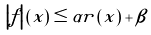Convert formula to latex. <formula><loc_0><loc_0><loc_500><loc_500>\left | f \right | \left ( x \right ) \leq \alpha r \left ( x \right ) + \beta</formula> 